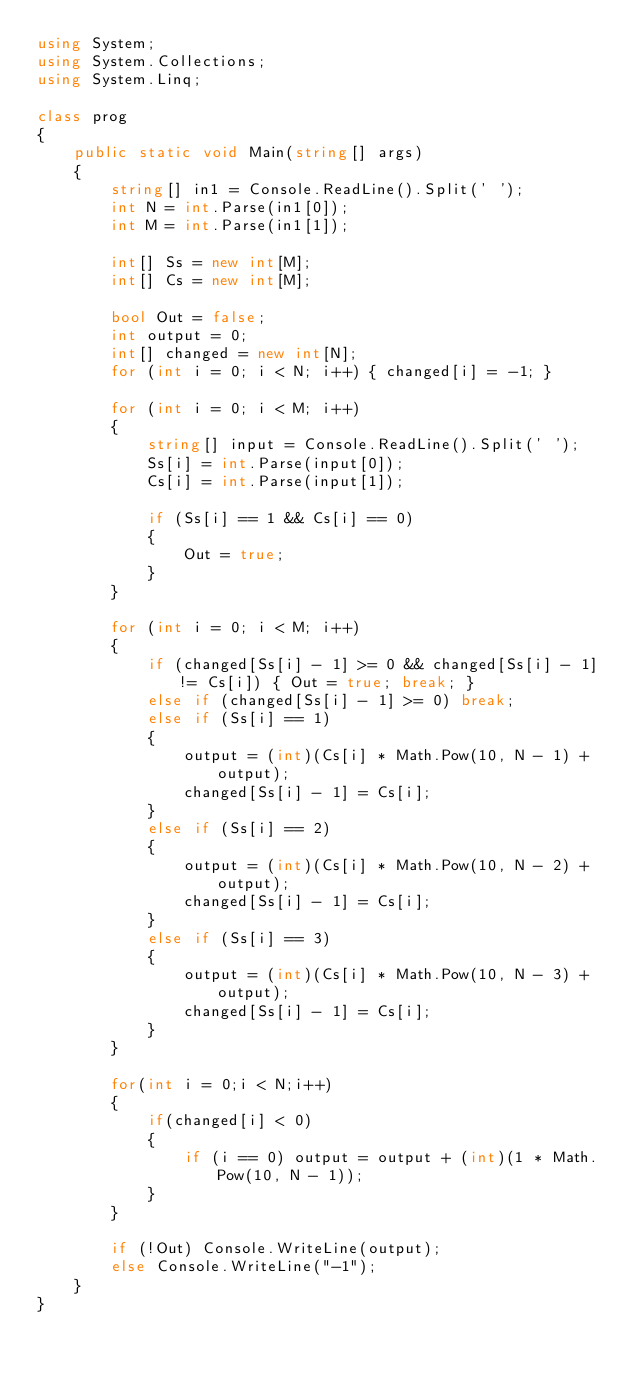<code> <loc_0><loc_0><loc_500><loc_500><_C#_>using System;
using System.Collections;
using System.Linq;

class prog
{
    public static void Main(string[] args)
    {
        string[] in1 = Console.ReadLine().Split(' ');
        int N = int.Parse(in1[0]);
        int M = int.Parse(in1[1]);

        int[] Ss = new int[M];
        int[] Cs = new int[M];

        bool Out = false;
        int output = 0;
        int[] changed = new int[N];
        for (int i = 0; i < N; i++) { changed[i] = -1; }

        for (int i = 0; i < M; i++)
        {
            string[] input = Console.ReadLine().Split(' ');
            Ss[i] = int.Parse(input[0]);
            Cs[i] = int.Parse(input[1]);

            if (Ss[i] == 1 && Cs[i] == 0)
            {
                Out = true;
            }
        }

        for (int i = 0; i < M; i++)
        {
            if (changed[Ss[i] - 1] >= 0 && changed[Ss[i] - 1] != Cs[i]) { Out = true; break; }
            else if (changed[Ss[i] - 1] >= 0) break;
            else if (Ss[i] == 1)
            {
                output = (int)(Cs[i] * Math.Pow(10, N - 1) + output);
                changed[Ss[i] - 1] = Cs[i];
            }
            else if (Ss[i] == 2)
            {
                output = (int)(Cs[i] * Math.Pow(10, N - 2) + output);
                changed[Ss[i] - 1] = Cs[i];
            }
            else if (Ss[i] == 3)
            {
                output = (int)(Cs[i] * Math.Pow(10, N - 3) + output);
                changed[Ss[i] - 1] = Cs[i];
            }
        }

        for(int i = 0;i < N;i++)
        {
            if(changed[i] < 0)
            {
                if (i == 0) output = output + (int)(1 * Math.Pow(10, N - 1));
            }
        }

        if (!Out) Console.WriteLine(output);
        else Console.WriteLine("-1");
    }
}</code> 